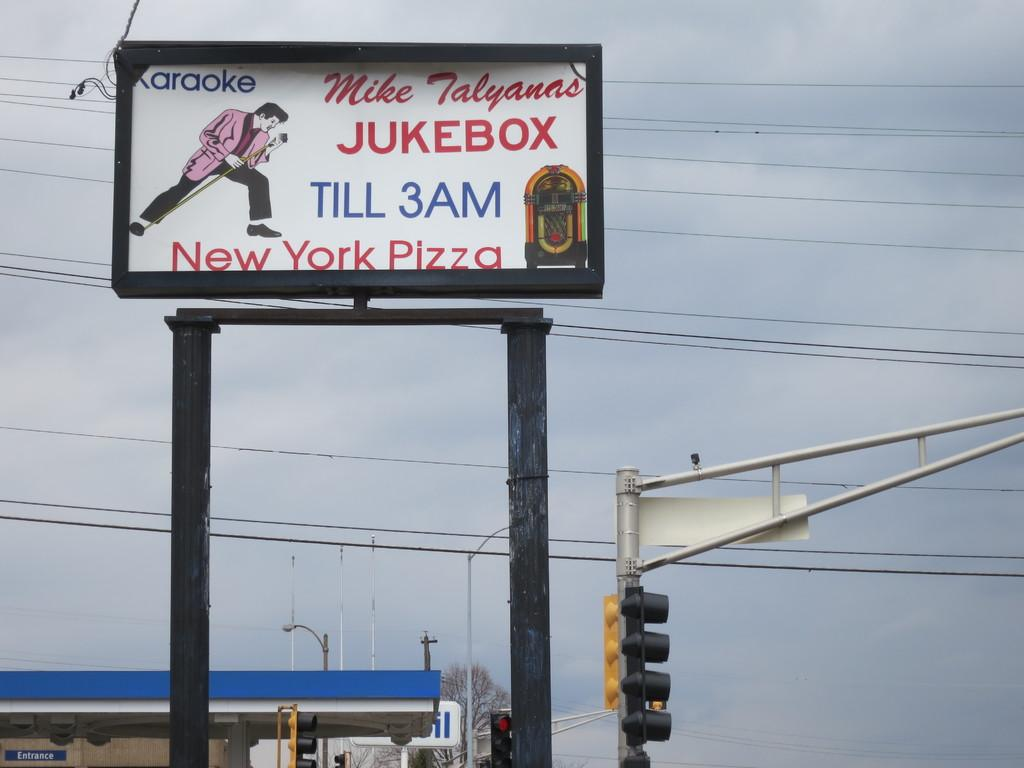What is the main subject of the image? The main subject of the image is a hoarding. What other objects can be seen in the image? There are poles, traffic signals, wires, and a shed visible in the image. What is present in the background of the image? In the background of the image, there are poles, lights, boards, a wall, a tree, and sky. Can you describe the wires in the image? The wires are likely used for electrical or communication purposes. What might the hoarding be advertising or promoting? The content of the hoarding cannot be determined from the image alone. How many masses can be seen in the image? There is no mass present in the image. What type of net is being used to catch the birds in the image? There are no birds or nets present in the image. 